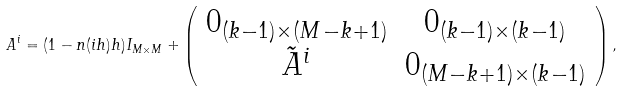Convert formula to latex. <formula><loc_0><loc_0><loc_500><loc_500>A ^ { i } = ( 1 - n ( i h ) h ) I _ { M \times M } + \left ( \begin{array} { c c } 0 _ { ( k - 1 ) \times ( M - k + 1 ) } & 0 _ { ( k - 1 ) \times ( k - 1 ) } \\ \tilde { A } ^ { i } & 0 _ { ( M - k + 1 ) \times ( k - 1 ) } \end{array} \right ) ,</formula> 